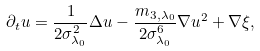<formula> <loc_0><loc_0><loc_500><loc_500>\partial _ { t } u = \frac { 1 } { 2 \sigma _ { \lambda _ { 0 } } ^ { 2 } } \Delta u - \frac { m _ { 3 , \lambda _ { 0 } } } { 2 \sigma _ { \lambda _ { 0 } } ^ { 6 } } \nabla u ^ { 2 } + \nabla \xi ,</formula> 